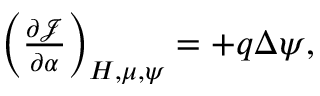<formula> <loc_0><loc_0><loc_500><loc_500>\begin{array} { r } { \left ( \frac { \partial \mathcal { J } } { \partial \alpha } \right ) _ { H , \mu , \psi } = + q \Delta \psi , } \end{array}</formula> 